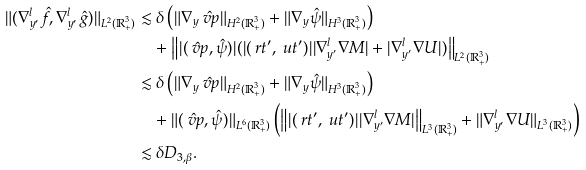<formula> <loc_0><loc_0><loc_500><loc_500>\| ( \nabla _ { y ^ { \prime } } ^ { l } \hat { f } , \nabla _ { y ^ { \prime } } ^ { l } \hat { g } ) \| _ { L ^ { 2 } ( \mathbb { R } ^ { 3 } _ { + } ) } & \lesssim \delta \left ( \| \nabla _ { y } \hat { \ v p } \| _ { H ^ { 2 } ( \mathbb { R } ^ { 3 } _ { + } ) } + \| \nabla _ { y } \hat { \psi } \| _ { H ^ { 3 } ( \mathbb { R } ^ { 3 } _ { + } ) } \right ) \\ & \quad + \left \| | ( \hat { \ v p } , \hat { \psi } ) | ( | ( \ r t ^ { \prime } , \ u t ^ { \prime } ) | | \nabla ^ { l } _ { y ^ { \prime } } \nabla M | + | \nabla ^ { l } _ { y ^ { \prime } } \nabla U | ) \right \| _ { L ^ { 2 } ( \mathbb { R } ^ { 3 } _ { + } ) } \\ & \lesssim \delta \left ( \| \nabla _ { y } \hat { \ v p } \| _ { H ^ { 2 } ( \mathbb { R } ^ { 3 } _ { + } ) } + \| \nabla _ { y } \hat { \psi } \| _ { H ^ { 3 } ( \mathbb { R } ^ { 3 } _ { + } ) } \right ) \\ & \quad + \| ( \hat { \ v p } , \hat { \psi } ) \| _ { L ^ { 6 } ( \mathbb { R } ^ { 3 } _ { + } ) } \left ( \left \| | ( \ r t ^ { \prime } , \ u t ^ { \prime } ) | | \nabla ^ { l } _ { y ^ { \prime } } \nabla M | \right \| _ { L ^ { 3 } ( \mathbb { R } ^ { 3 } _ { + } ) } + \| \nabla ^ { l } _ { y ^ { \prime } } \nabla U \| _ { L ^ { 3 } ( \mathbb { R } ^ { 3 } _ { + } ) } \right ) \\ & \lesssim \delta D _ { 3 , \beta } .</formula> 